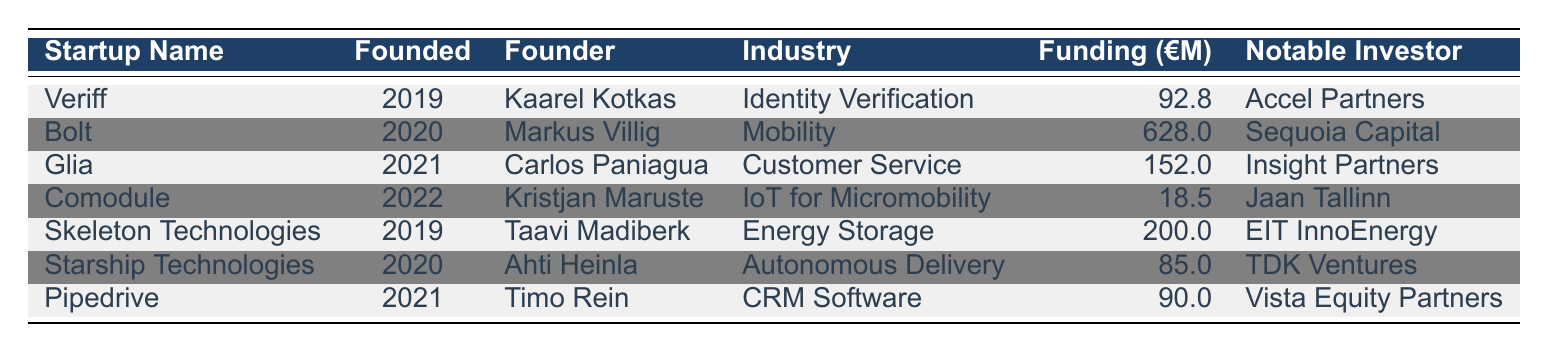What is the total funding amount for all startups founded after 2019? To find the total funding amount, I will sum the funding amounts for all startups founded in 2020, 2021, and 2022. The relevant funding amounts are: Bolt (628), Glia (152), Comodule (18.5), Starship Technologies (85), and Pipedrive (90). Summing these values: 628 + 152 + 18.5 + 85 + 90 = 973.5.
Answer: 973.5 Which startup in the table has the highest funding? By inspecting the funding amounts listed for each startup, I notice that Bolt has the highest amount of funding at 628 million euros.
Answer: Bolt Is Veriff in the mobility industry? Veriff's industry is listed as Identity Verification in the table. Therefore, it is not in the mobility industry.
Answer: No Who is the founder of Glia? The founder of Glia, as listed in the table, is Carlos Paniagua. I directly reference the row corresponding to Glia to answer this.
Answer: Carlos Paniagua What is the average funding amount of all listed startups? To find the average funding, I first sum the funding amounts: 92.8 + 628 + 152 + 18.5 + 200 + 85 + 90 = 1266.3. There are 7 startups total, so I divide the total funding by the number of startups: 1266.3 / 7 ≈ 180.9.
Answer: 180.9 Is there a startup founded in 2022 that has received over 20 million euros in funding? Comodule, founded in 2022, received 18.5 million euros in funding, which does not exceed 20 million euros. Therefore, there is no startup founded in 2022 with over 20 million euros.
Answer: No How many startups were founded in 2021? Looking at the table, I can see two startups were founded in 2021: Glia and Pipedrive. Thus, the count is 2.
Answer: 2 Which notable investor has invested in the lowest funded startup listed? Comodule received the least funding among the listed startups at 18.5 million euros, and its notable investor is Jaan Tallinn. Therefore, Jaan Tallinn is the investor for the lowest funded startup.
Answer: Jaan Tallinn 